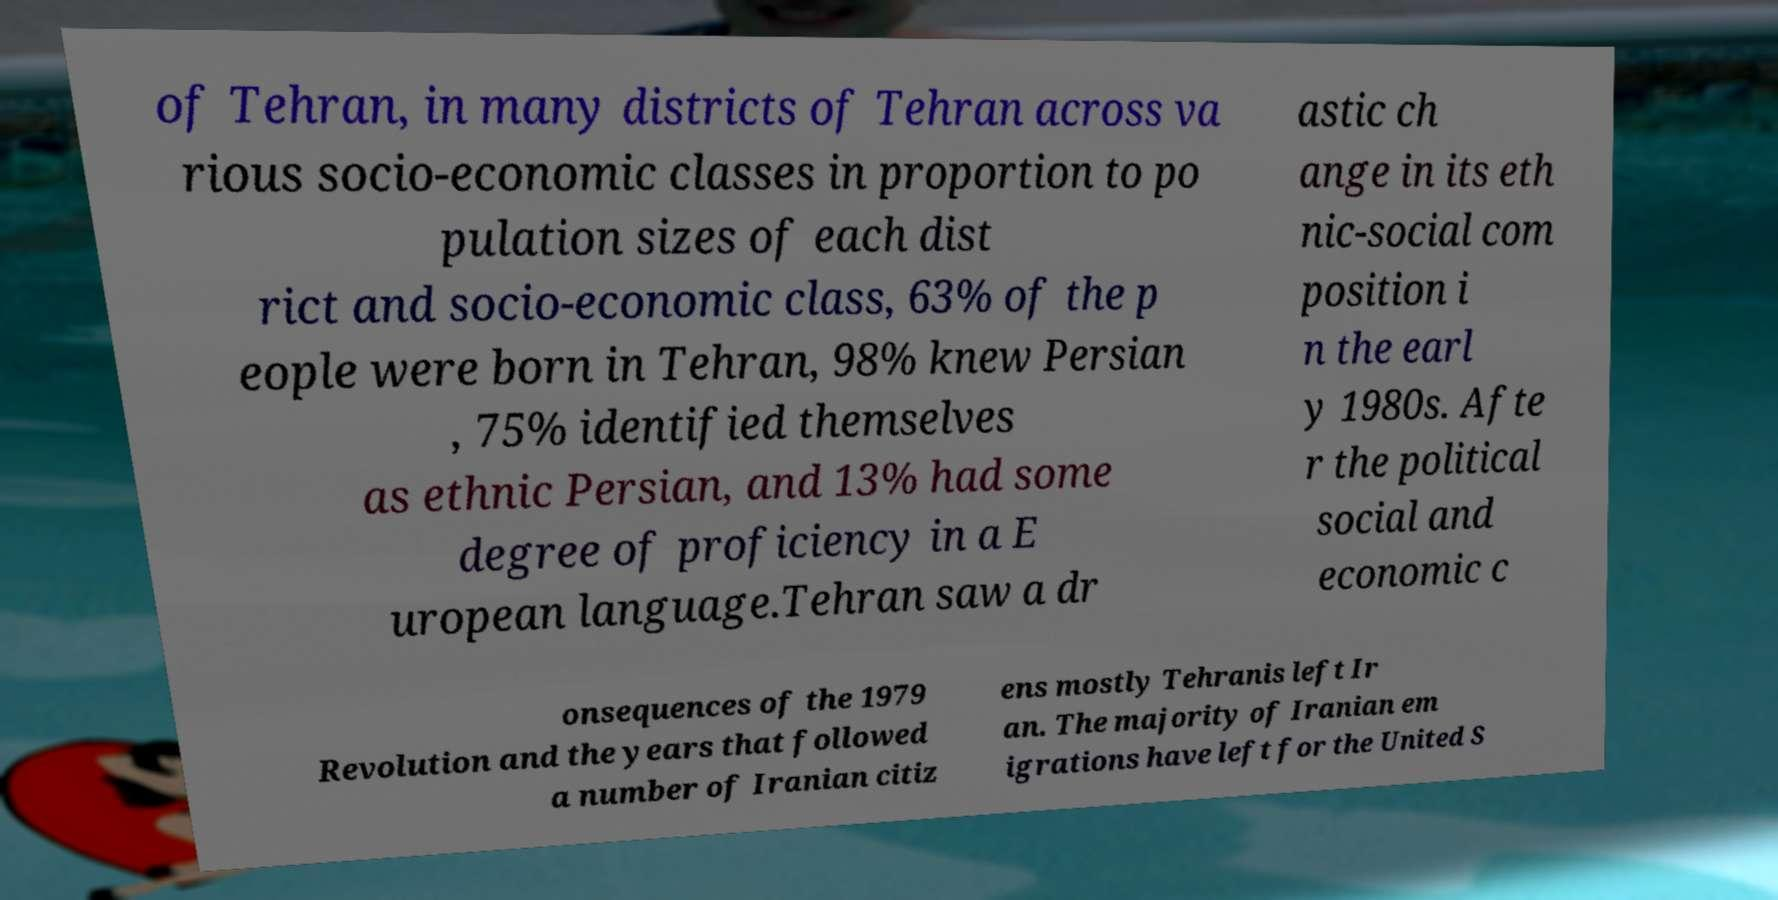I need the written content from this picture converted into text. Can you do that? of Tehran, in many districts of Tehran across va rious socio-economic classes in proportion to po pulation sizes of each dist rict and socio-economic class, 63% of the p eople were born in Tehran, 98% knew Persian , 75% identified themselves as ethnic Persian, and 13% had some degree of proficiency in a E uropean language.Tehran saw a dr astic ch ange in its eth nic-social com position i n the earl y 1980s. Afte r the political social and economic c onsequences of the 1979 Revolution and the years that followed a number of Iranian citiz ens mostly Tehranis left Ir an. The majority of Iranian em igrations have left for the United S 